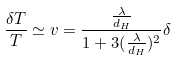Convert formula to latex. <formula><loc_0><loc_0><loc_500><loc_500>\frac { \delta T } { T } \simeq v = \frac { \frac { \lambda } { d _ { H } } } { 1 + 3 ( \frac { \lambda } { d _ { H } } ) ^ { 2 } } \delta</formula> 